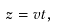Convert formula to latex. <formula><loc_0><loc_0><loc_500><loc_500>z = v t ,</formula> 